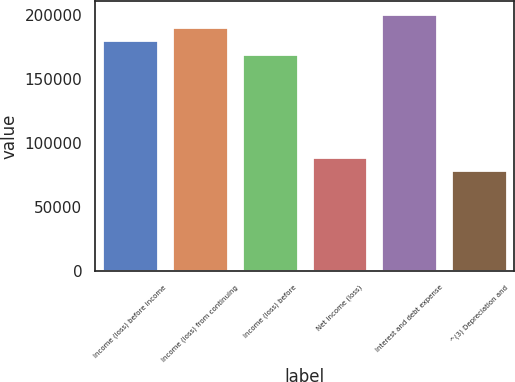Convert chart. <chart><loc_0><loc_0><loc_500><loc_500><bar_chart><fcel>Income (loss) before income<fcel>Income (loss) from continuing<fcel>Income (loss) before<fcel>Net income (loss)<fcel>Interest and debt expense<fcel>^(3) Depreciation and<nl><fcel>179976<fcel>190355<fcel>169596<fcel>89183.6<fcel>200735<fcel>78804<nl></chart> 